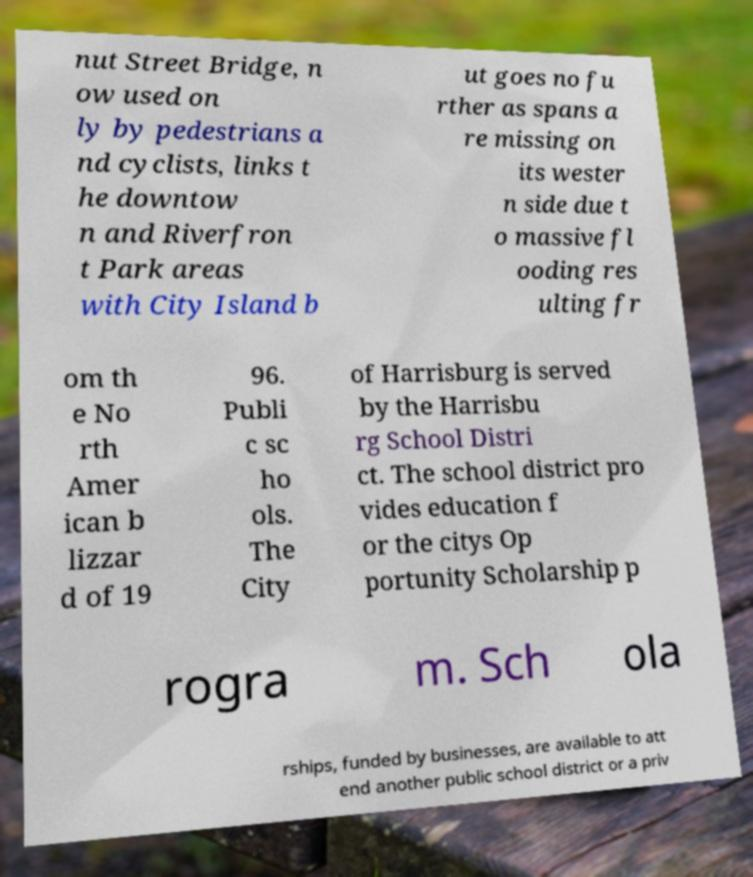I need the written content from this picture converted into text. Can you do that? nut Street Bridge, n ow used on ly by pedestrians a nd cyclists, links t he downtow n and Riverfron t Park areas with City Island b ut goes no fu rther as spans a re missing on its wester n side due t o massive fl ooding res ulting fr om th e No rth Amer ican b lizzar d of 19 96. Publi c sc ho ols. The City of Harrisburg is served by the Harrisbu rg School Distri ct. The school district pro vides education f or the citys Op portunity Scholarship p rogra m. Sch ola rships, funded by businesses, are available to att end another public school district or a priv 